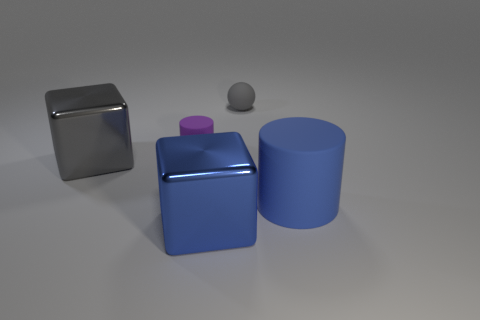Add 4 small red balls. How many objects exist? 9 Subtract all spheres. How many objects are left? 4 Subtract all big brown rubber balls. Subtract all gray shiny things. How many objects are left? 4 Add 5 gray metallic things. How many gray metallic things are left? 6 Add 4 gray metal cylinders. How many gray metal cylinders exist? 4 Subtract 0 yellow spheres. How many objects are left? 5 